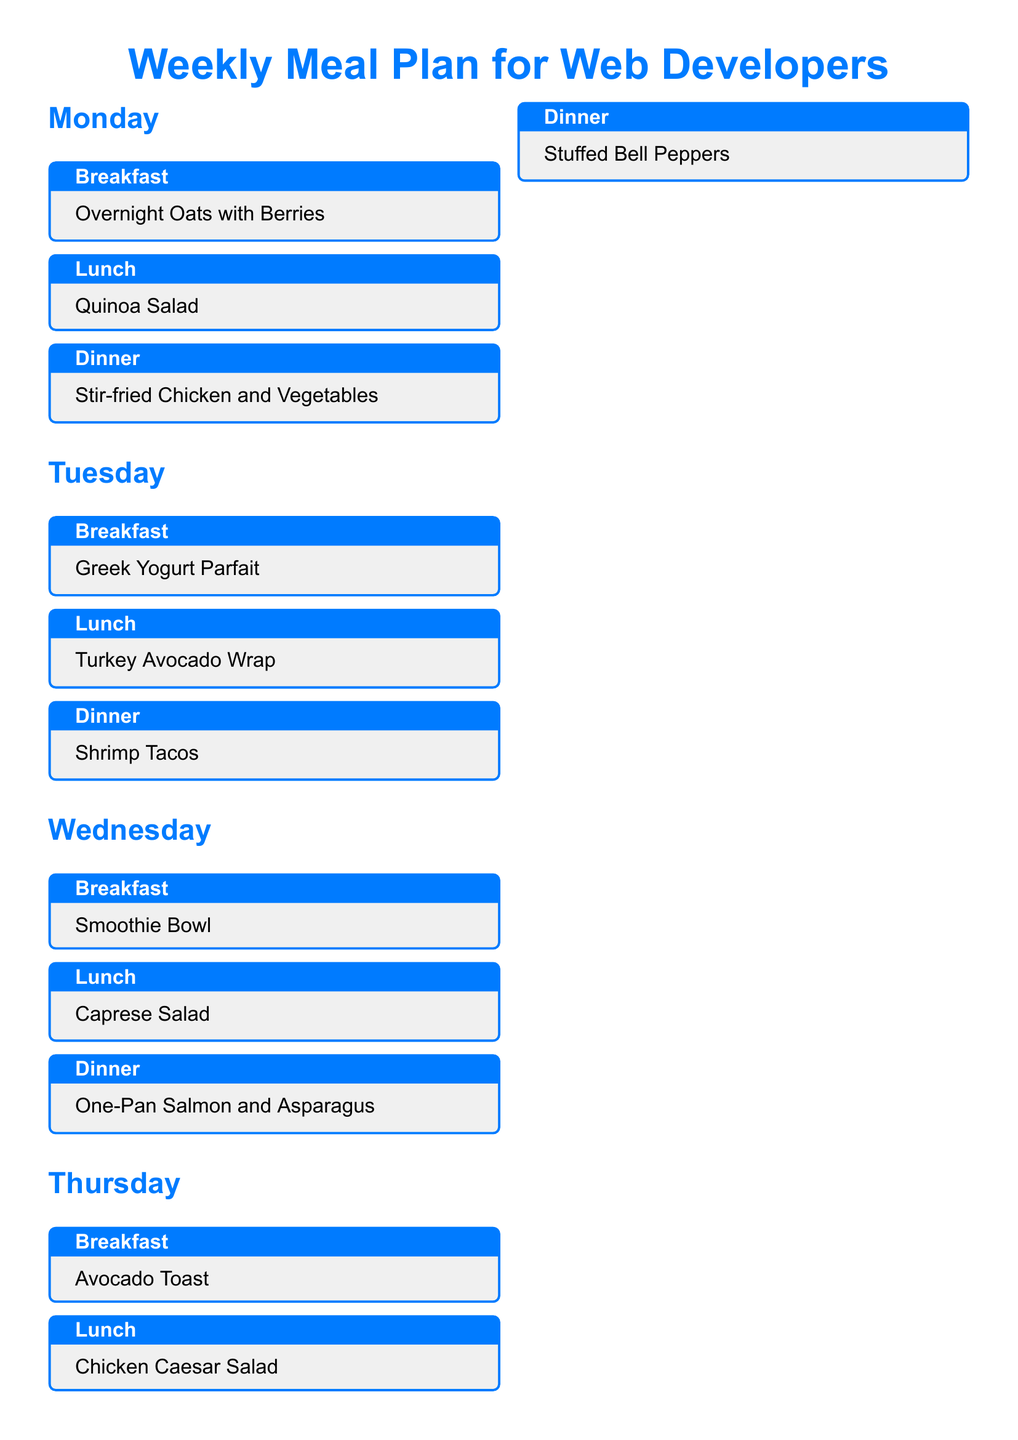What is the breakfast for Monday? The breakfast for Monday is stated in the meal plan as "Overnight Oats with Berries."
Answer: Overnight Oats with Berries What is Tuesday's dinner? The meal plan specifies "Shrimp Tacos" as the dinner for Tuesday.
Answer: Shrimp Tacos Which meal is listed for Friday lunch? According to the document, "Mediterranean Platter" is the lunch meal listed for Friday.
Answer: Mediterranean Platter What does the meal prep tip suggest doing on Sunday? The document states that the meal prep tip suggests "Pre-cut vegetables, portion out snacks, and cook grains to save time during the week."
Answer: Pre-cut vegetables, portion out snacks, and cook grains How many dinners are provided in the meal plan? The document lists one dinner for each day of the week, totaling seven dinners.
Answer: Seven What type of cuisine is emphasized in the Saturday lunch? The Saturday lunch features "Chicken and Veggie Wrap," emphasizing a combination of protein and vegetables.
Answer: Chicken and Veggie Wrap What healthy snack options are recommended? The document mentions "nuts, fruit, and yogurt" as healthy snack options to keep on hand.
Answer: Nuts, fruit, and yogurt Which meal is recommended for Sunday dinner? The meal plan specifies "Veggie Pizza" as the dinner for Sunday.
Answer: Veggie Pizza 